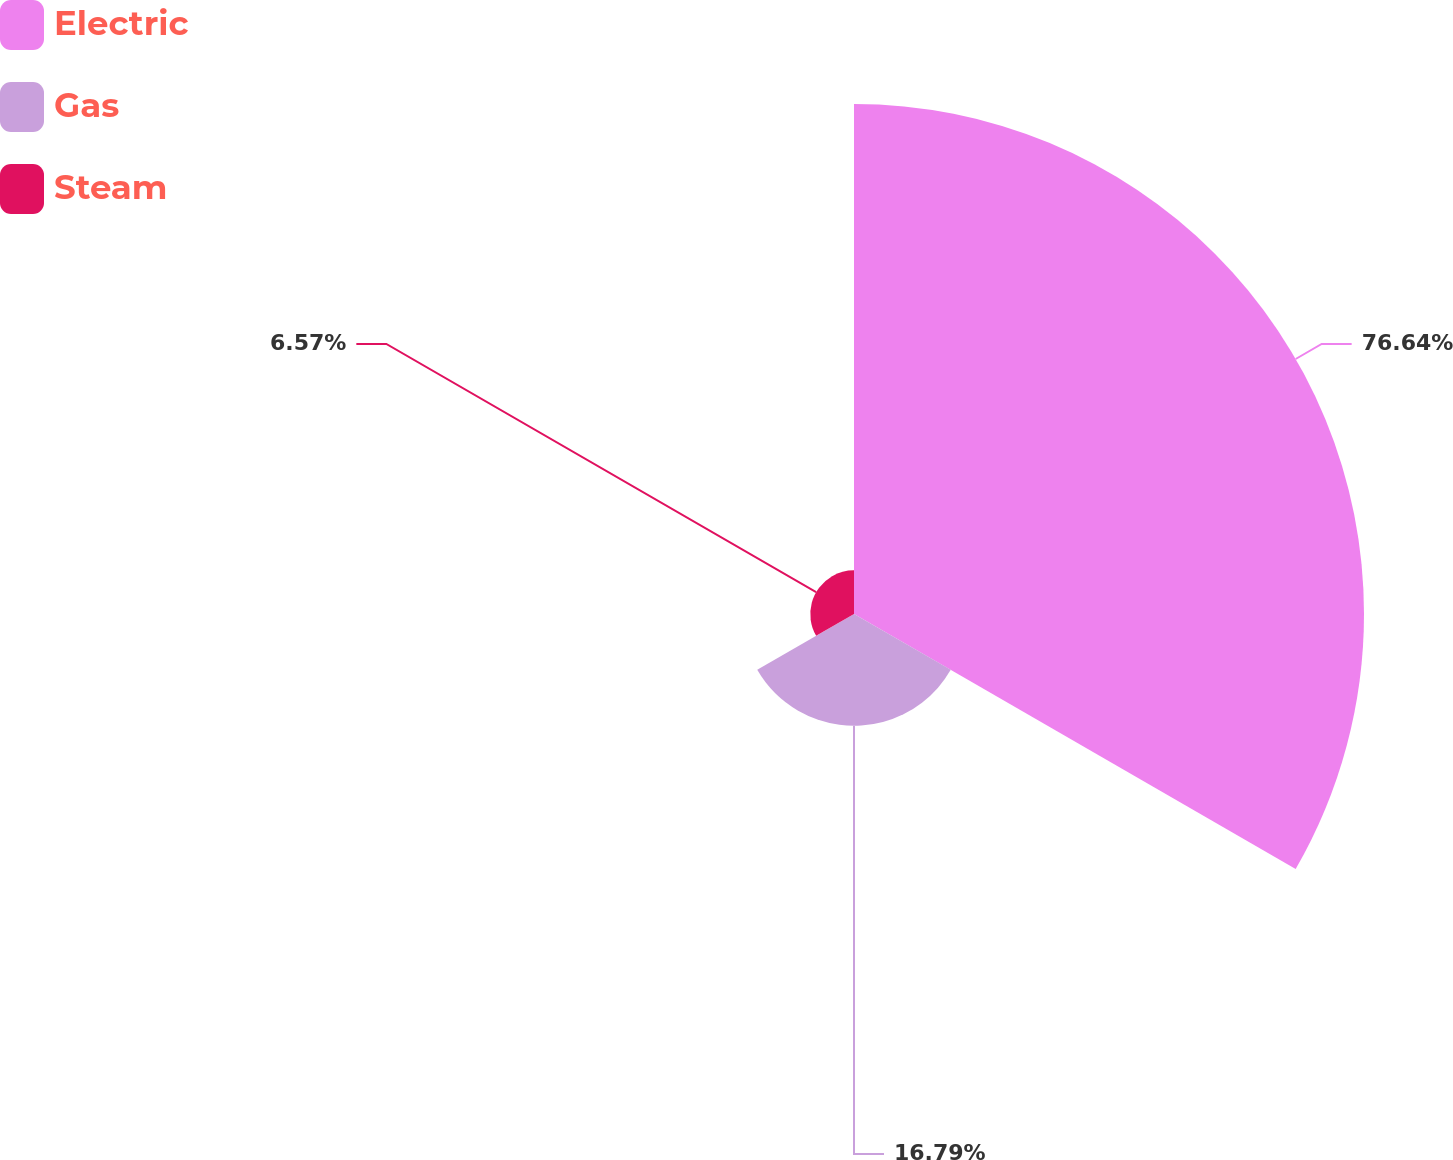<chart> <loc_0><loc_0><loc_500><loc_500><pie_chart><fcel>Electric<fcel>Gas<fcel>Steam<nl><fcel>76.64%<fcel>16.79%<fcel>6.57%<nl></chart> 